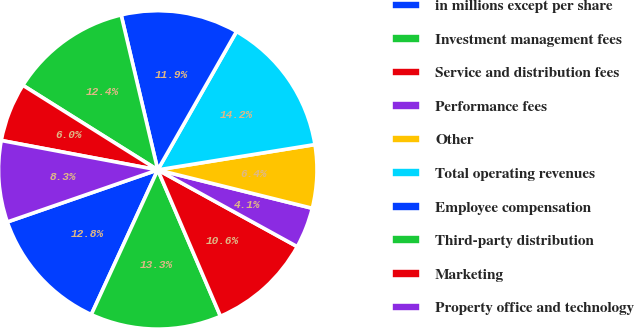Convert chart. <chart><loc_0><loc_0><loc_500><loc_500><pie_chart><fcel>in millions except per share<fcel>Investment management fees<fcel>Service and distribution fees<fcel>Performance fees<fcel>Other<fcel>Total operating revenues<fcel>Employee compensation<fcel>Third-party distribution<fcel>Marketing<fcel>Property office and technology<nl><fcel>12.84%<fcel>13.3%<fcel>10.55%<fcel>4.13%<fcel>6.42%<fcel>14.22%<fcel>11.93%<fcel>12.39%<fcel>5.96%<fcel>8.26%<nl></chart> 